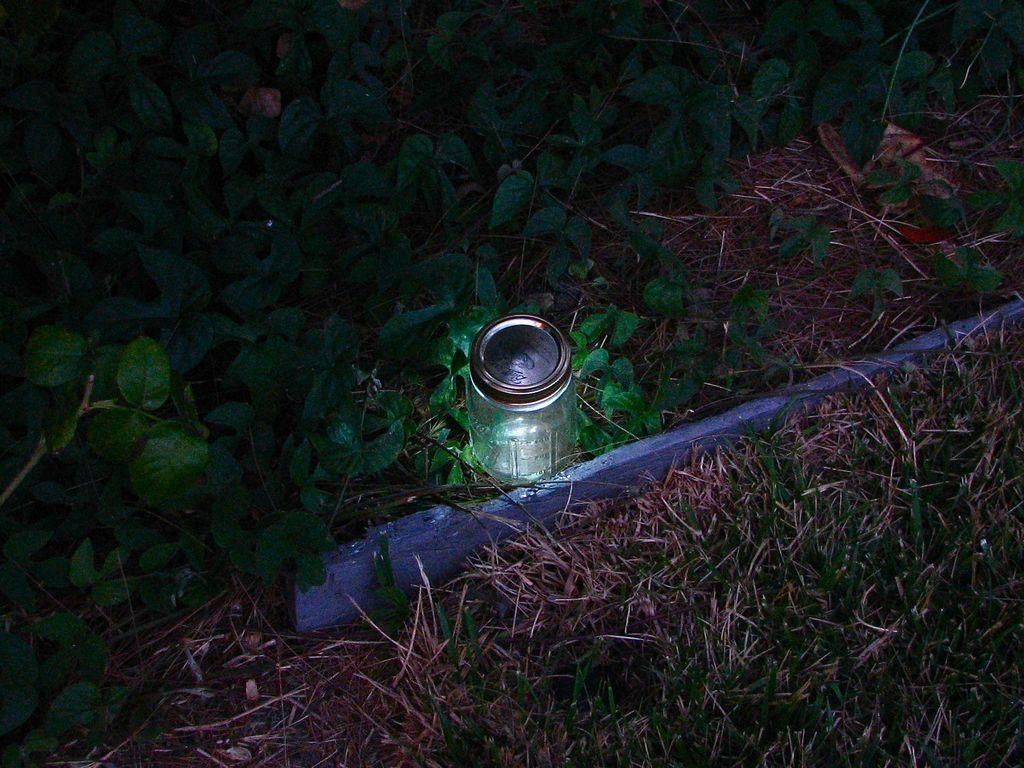What object is visible in the image that is typically used for holding liquids? There is a glass in the image. What living organism can be seen in the image? There is a plant in the image. Who is the representative of the turkey in the image? There is no representative of a turkey present in the image. What type of shock can be seen in the image? There is no shock present in the image. 